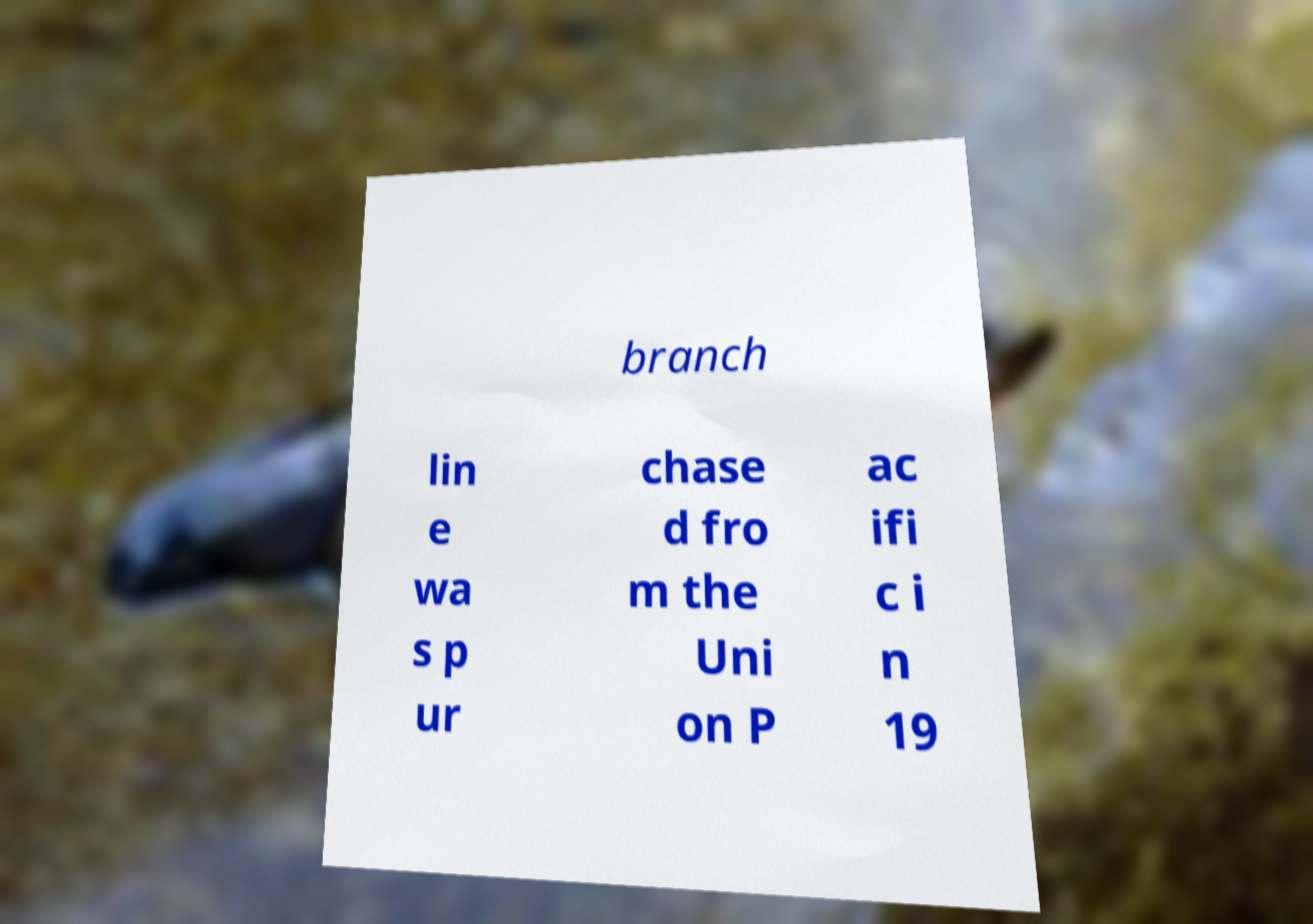There's text embedded in this image that I need extracted. Can you transcribe it verbatim? branch lin e wa s p ur chase d fro m the Uni on P ac ifi c i n 19 